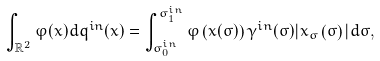Convert formula to latex. <formula><loc_0><loc_0><loc_500><loc_500>\int _ { { \mathbb { R } } ^ { 2 } } \varphi ( x ) d q ^ { i n } ( x ) = \int _ { \sigma _ { 0 } ^ { i n } } ^ { \sigma _ { 1 } ^ { i n } } \varphi \left ( x ( \sigma ) \right ) \gamma ^ { i n } ( \sigma ) | x _ { \sigma } \left ( \sigma \right ) | d \sigma ,</formula> 